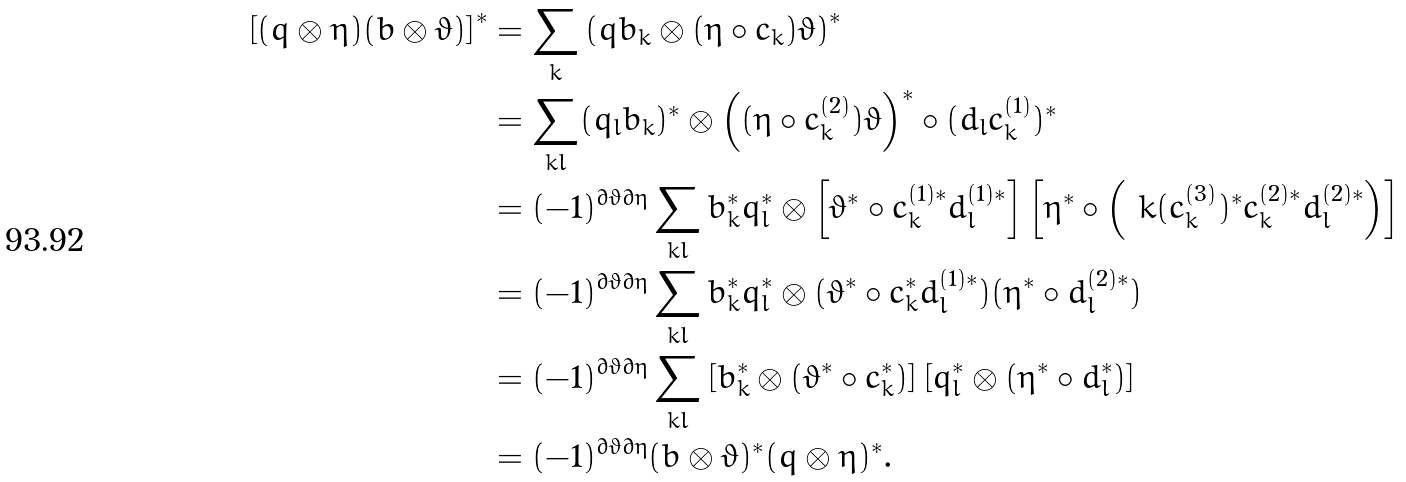<formula> <loc_0><loc_0><loc_500><loc_500>\left [ ( q \otimes \eta ) ( b \otimes \vartheta ) \right ] ^ { * } & = \sum _ { k } \left ( q b _ { k } \otimes ( \eta \circ c _ { k } ) \vartheta \right ) ^ { * } \\ & = \sum _ { k l } ( q _ { l } b _ { k } ) ^ { * } \otimes \left ( ( \eta \circ c _ { k } ^ { ( 2 ) } ) \vartheta \right ) ^ { * } \circ ( d _ { l } c _ { k } ^ { ( 1 ) } ) ^ { * } \\ & = ( - 1 ) ^ { \partial \vartheta \partial \eta } \sum _ { k l } b _ { k } ^ { * } q _ { l } ^ { * } \otimes \left [ \vartheta ^ { * } \circ c _ { k } ^ { ( 1 ) * } d _ { l } ^ { ( 1 ) * } \right ] \left [ \eta ^ { * } \circ \left ( \ k ( c _ { k } ^ { ( 3 ) } ) ^ { * } c _ { k } ^ { ( 2 ) * } d _ { l } ^ { ( 2 ) * } \right ) \right ] \\ & = ( - 1 ) ^ { \partial \vartheta \partial \eta } \sum _ { k l } b _ { k } ^ { * } q _ { l } ^ { * } \otimes ( \vartheta ^ { * } \circ c _ { k } ^ { * } d _ { l } ^ { ( 1 ) * } ) ( \eta ^ { * } \circ d _ { l } ^ { ( 2 ) * } ) \\ & = ( - 1 ) ^ { \partial \vartheta \partial \eta } \sum _ { k l } \left [ b _ { k } ^ { * } \otimes ( \vartheta ^ { * } \circ c _ { k } ^ { * } ) \right ] \left [ q _ { l } ^ { * } \otimes ( \eta ^ { * } \circ d _ { l } ^ { * } ) \right ] \\ & = ( - 1 ) ^ { \partial \vartheta \partial \eta } ( b \otimes \vartheta ) ^ { * } ( q \otimes \eta ) ^ { * } .</formula> 